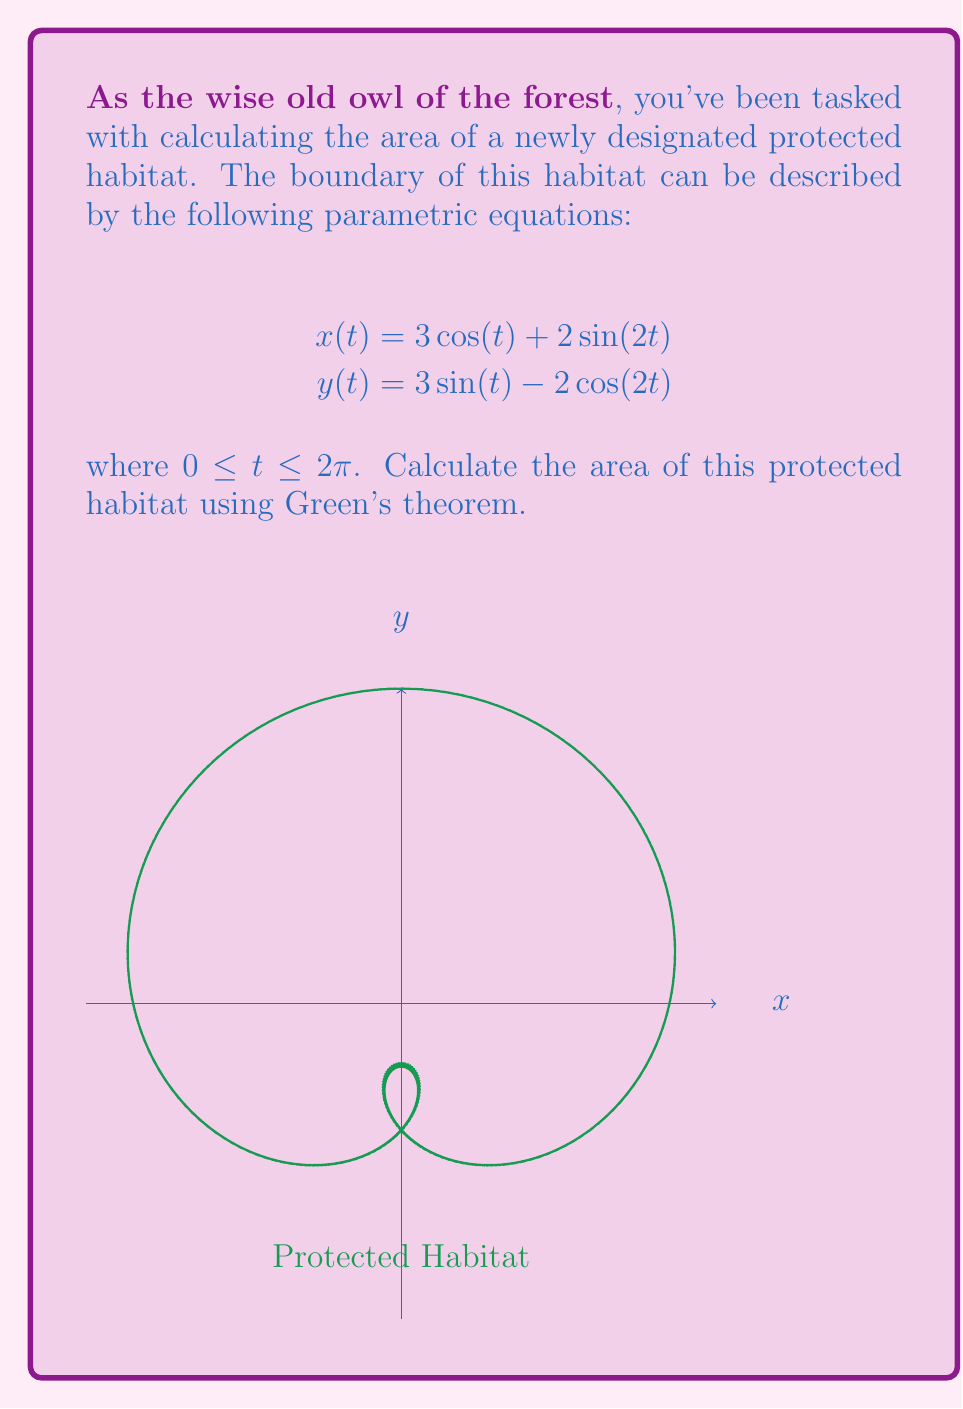Teach me how to tackle this problem. To solve this problem, we'll use Green's theorem, which states that for a closed curve C:

$$\oint_C (Ldx + Mdy) = \iint_R \left(\frac{\partial M}{\partial x} - \frac{\partial L}{\partial y}\right) dA$$

Where the left side is a line integral and the right side is a double integral over the region R enclosed by C.

For area calculation, we can choose $L = -y/2$ and $M = x/2$. This gives us:

$$\text{Area} = \frac{1}{2}\oint_C (xdy - ydx)$$

Step 1: Calculate $dx$ and $dy$
$$dx = \frac{dx}{dt}dt = (-3\sin(t) + 4\cos(2t))dt$$
$$dy = \frac{dy}{dt}dt = (3\cos(t) + 4\sin(2t))dt$$

Step 2: Substitute into the area formula
$$\text{Area} = \frac{1}{2}\int_0^{2\pi} [(3\cos(t) + 2\sin(2t))(3\cos(t) + 4\sin(2t)) \\
+ (3\sin(t) - 2\cos(2t))(3\sin(t) - 4\cos(2t))]dt$$

Step 3: Expand the integrand
$$\text{Area} = \frac{1}{2}\int_0^{2\pi} [9\cos^2(t) + 12\cos(t)\sin(2t) + 6\sin(2t)\cos(t) + 8\sin^2(2t) \\
+ 9\sin^2(t) - 12\sin(t)\cos(2t) - 6\cos(2t)\sin(t) + 8\cos^2(2t)]dt$$

Step 4: Simplify using trigonometric identities
$$\text{Area} = \frac{1}{2}\int_0^{2\pi} [9(\cos^2(t) + \sin^2(t)) + 18\cos(t)\sin(2t) \\
- 18\sin(t)\cos(2t) + 8(\sin^2(2t) + \cos^2(2t))]dt$$
$$= \frac{1}{2}\int_0^{2\pi} [9 + 18(\cos(t)\sin(2t) - \sin(t)\cos(2t)) + 8]dt$$
$$= \frac{1}{2}\int_0^{2\pi} [17 + 18\sin(t)]dt$$

Step 5: Integrate
$$\text{Area} = \frac{1}{2}[17t - 18\cos(t)]_0^{2\pi}$$
$$= \frac{1}{2}[34\pi - 18(\cos(2\pi) - \cos(0))]$$
$$= 17\pi$$
Answer: $17\pi$ square units 